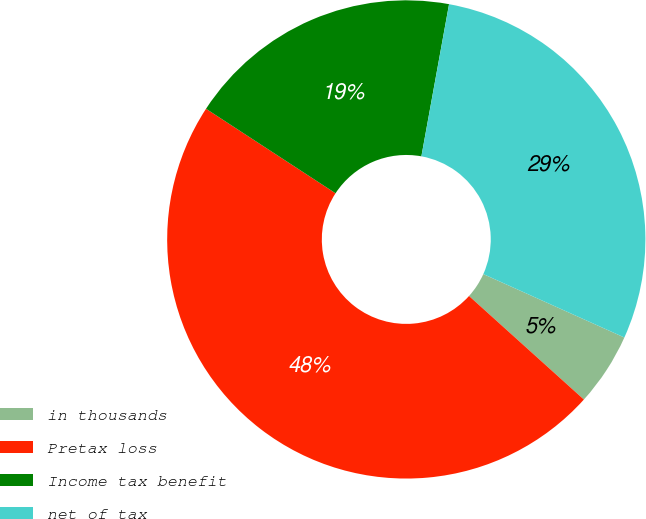<chart> <loc_0><loc_0><loc_500><loc_500><pie_chart><fcel>in thousands<fcel>Pretax loss<fcel>Income tax benefit<fcel>net of tax<nl><fcel>4.95%<fcel>47.52%<fcel>18.66%<fcel>28.86%<nl></chart> 